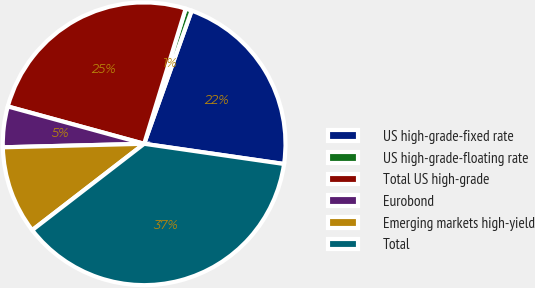<chart> <loc_0><loc_0><loc_500><loc_500><pie_chart><fcel>US high-grade-fixed rate<fcel>US high-grade-floating rate<fcel>Total US high-grade<fcel>Eurobond<fcel>Emerging markets high-yield<fcel>Total<nl><fcel>21.83%<fcel>0.71%<fcel>25.49%<fcel>4.65%<fcel>10.06%<fcel>37.26%<nl></chart> 